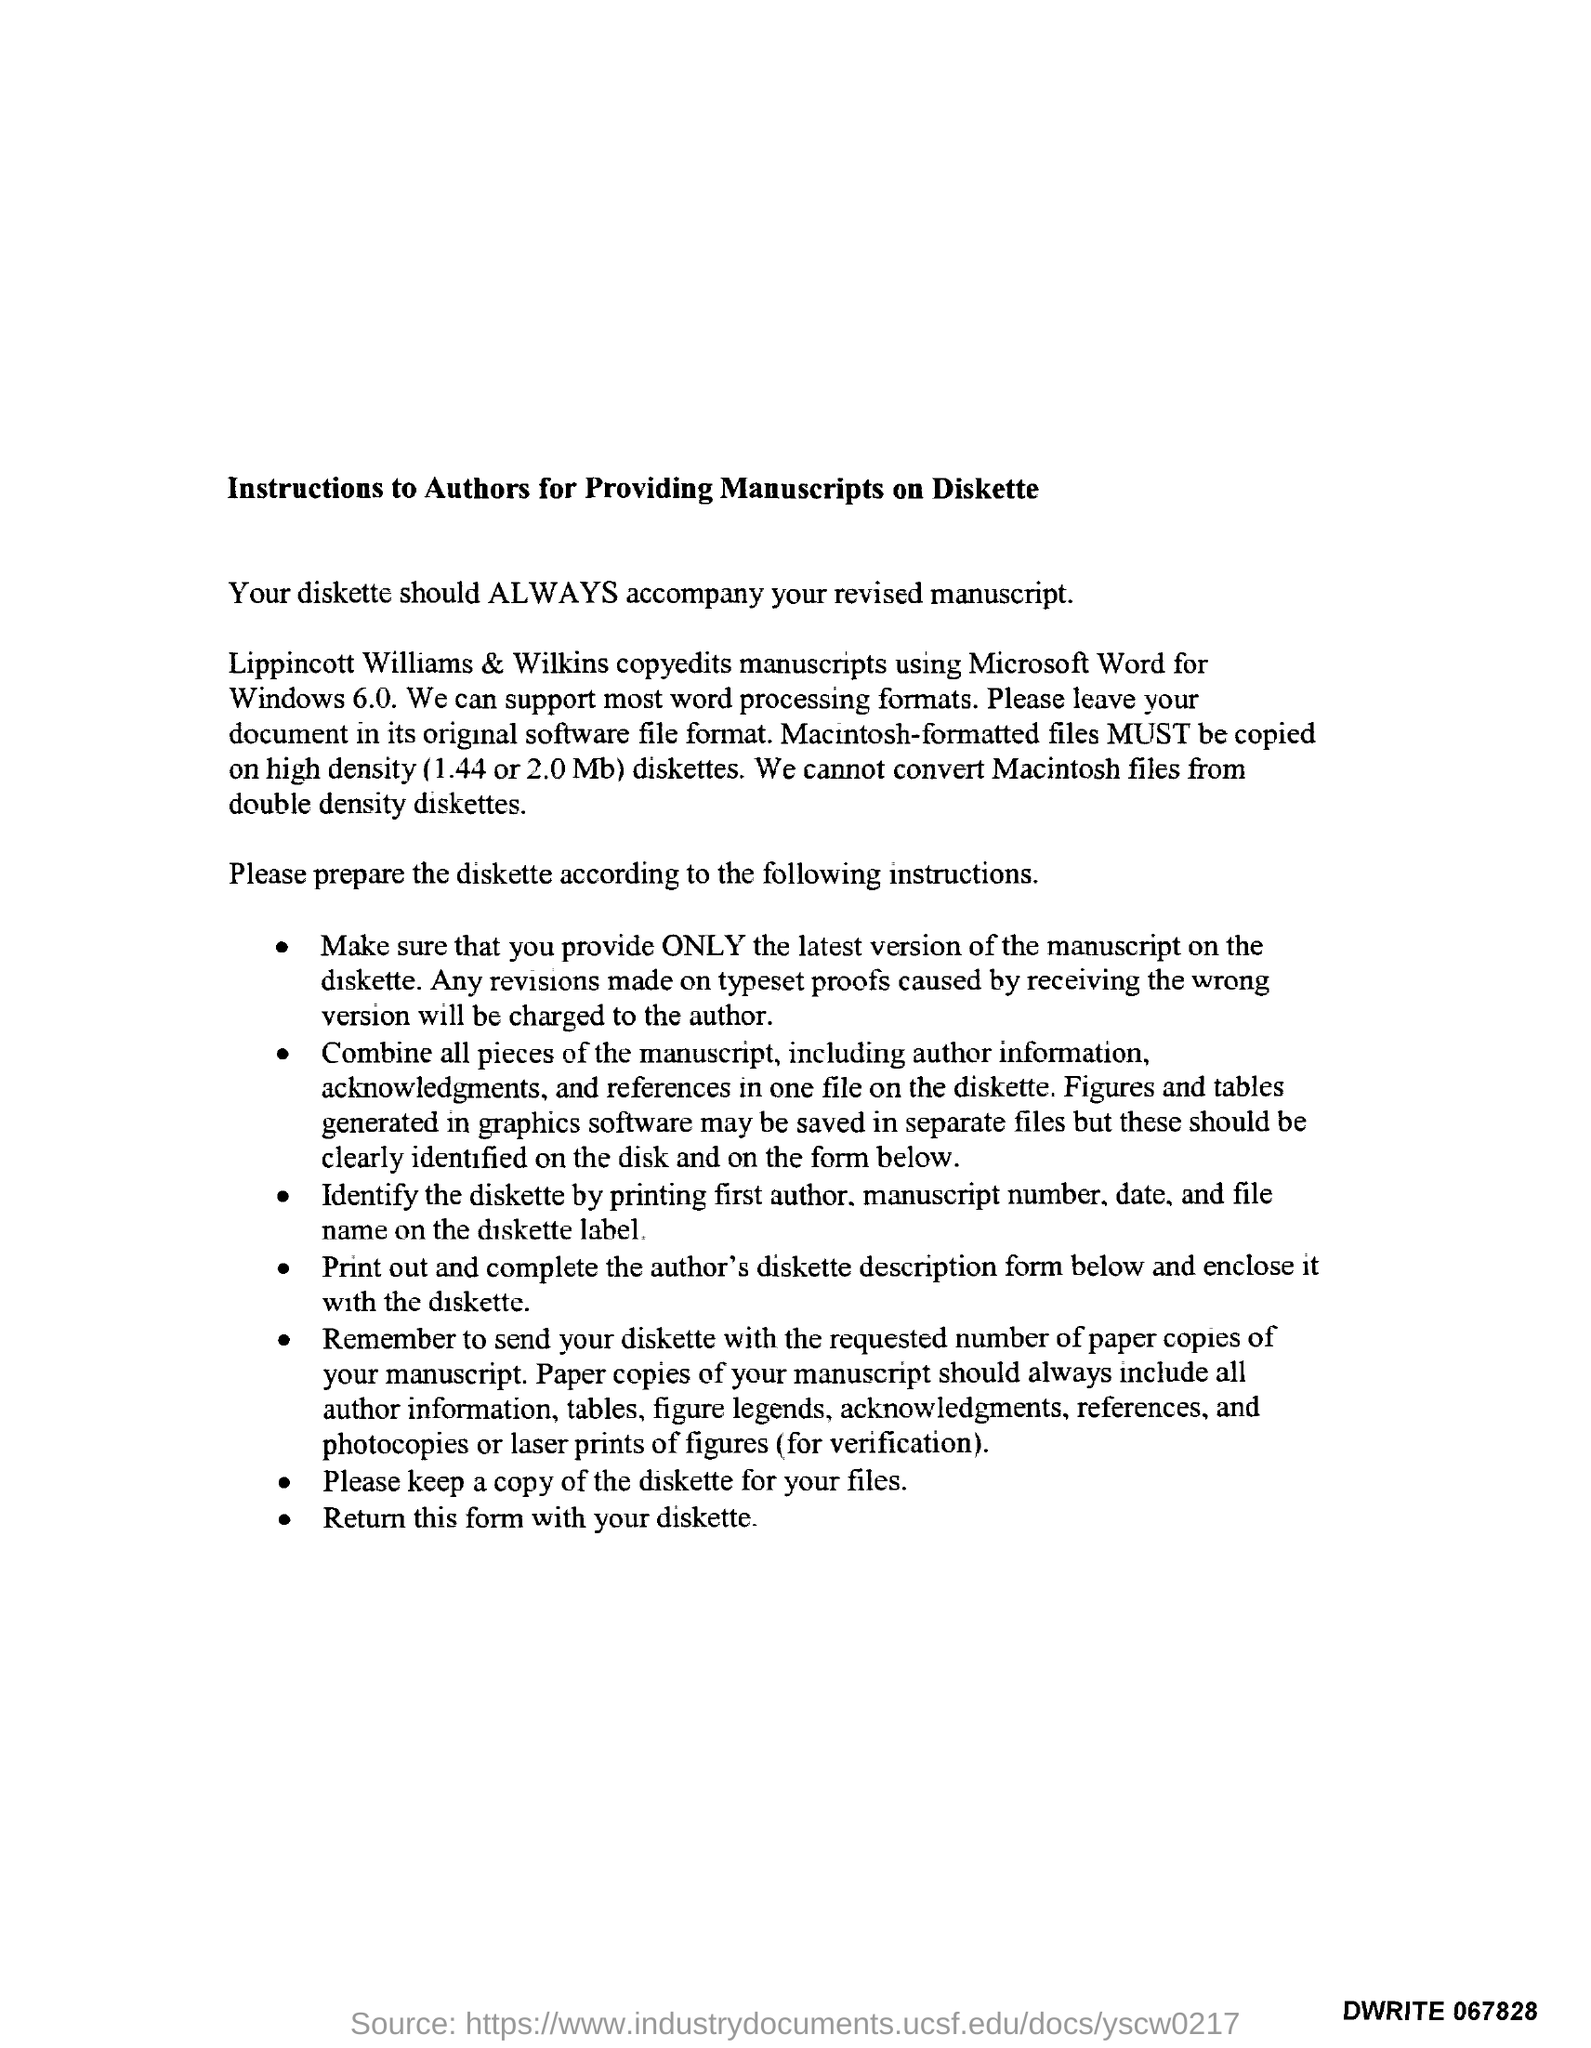Give some essential details in this illustration. It is necessary to provide manuscripts on diskette in accordance with the instructions for authors titled 'What is the title of the document?' 